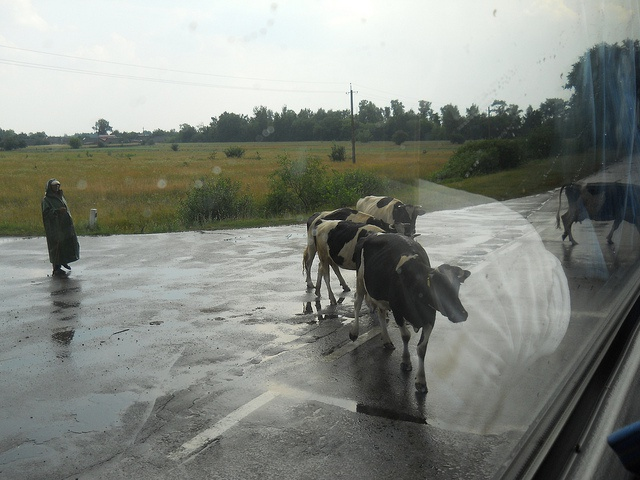Describe the objects in this image and their specific colors. I can see cow in white, black, gray, and darkgray tones, cow in white, black, gray, darkblue, and purple tones, people in white, black, gray, darkgreen, and darkgray tones, cow in white, black, gray, and darkgray tones, and cow in white, gray, black, and darkgray tones in this image. 